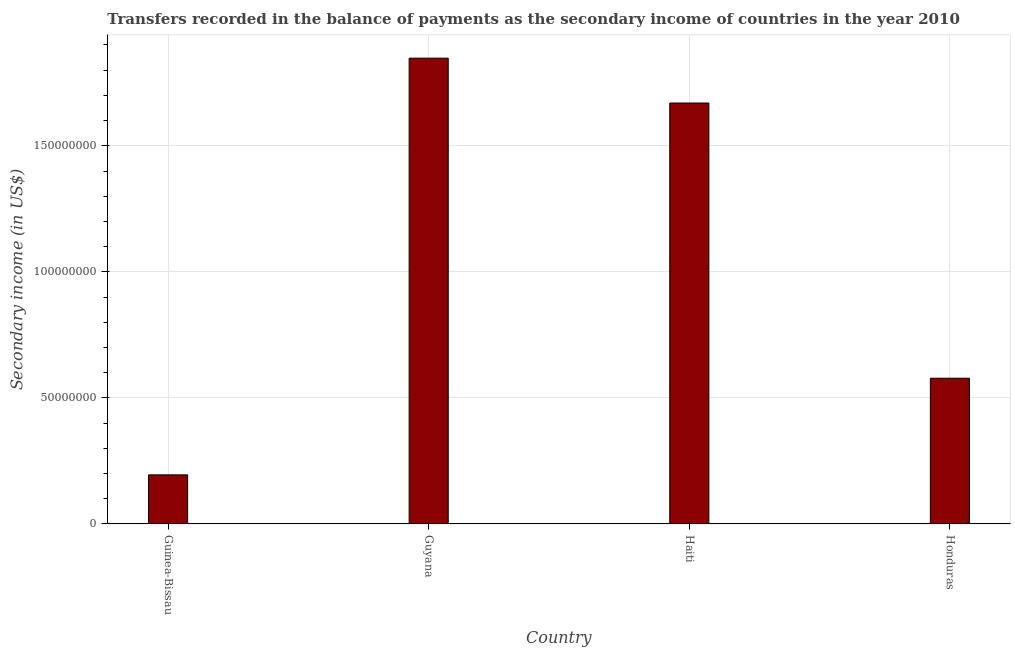Does the graph contain any zero values?
Offer a very short reply. No. What is the title of the graph?
Offer a very short reply. Transfers recorded in the balance of payments as the secondary income of countries in the year 2010. What is the label or title of the Y-axis?
Your answer should be very brief. Secondary income (in US$). What is the amount of secondary income in Haiti?
Offer a terse response. 1.67e+08. Across all countries, what is the maximum amount of secondary income?
Your answer should be compact. 1.85e+08. Across all countries, what is the minimum amount of secondary income?
Give a very brief answer. 1.95e+07. In which country was the amount of secondary income maximum?
Your answer should be compact. Guyana. In which country was the amount of secondary income minimum?
Provide a succinct answer. Guinea-Bissau. What is the sum of the amount of secondary income?
Your answer should be compact. 4.29e+08. What is the difference between the amount of secondary income in Guinea-Bissau and Honduras?
Keep it short and to the point. -3.83e+07. What is the average amount of secondary income per country?
Your answer should be very brief. 1.07e+08. What is the median amount of secondary income?
Give a very brief answer. 1.12e+08. In how many countries, is the amount of secondary income greater than 130000000 US$?
Provide a succinct answer. 2. What is the ratio of the amount of secondary income in Guinea-Bissau to that in Haiti?
Offer a very short reply. 0.12. Is the amount of secondary income in Guinea-Bissau less than that in Guyana?
Provide a succinct answer. Yes. Is the difference between the amount of secondary income in Guyana and Haiti greater than the difference between any two countries?
Your response must be concise. No. What is the difference between the highest and the second highest amount of secondary income?
Provide a short and direct response. 1.78e+07. What is the difference between the highest and the lowest amount of secondary income?
Your answer should be compact. 1.65e+08. How many countries are there in the graph?
Your response must be concise. 4. Are the values on the major ticks of Y-axis written in scientific E-notation?
Your response must be concise. No. What is the Secondary income (in US$) of Guinea-Bissau?
Your answer should be compact. 1.95e+07. What is the Secondary income (in US$) in Guyana?
Your answer should be very brief. 1.85e+08. What is the Secondary income (in US$) in Haiti?
Your answer should be compact. 1.67e+08. What is the Secondary income (in US$) of Honduras?
Offer a very short reply. 5.78e+07. What is the difference between the Secondary income (in US$) in Guinea-Bissau and Guyana?
Provide a short and direct response. -1.65e+08. What is the difference between the Secondary income (in US$) in Guinea-Bissau and Haiti?
Your answer should be compact. -1.47e+08. What is the difference between the Secondary income (in US$) in Guinea-Bissau and Honduras?
Your answer should be compact. -3.83e+07. What is the difference between the Secondary income (in US$) in Guyana and Haiti?
Keep it short and to the point. 1.78e+07. What is the difference between the Secondary income (in US$) in Guyana and Honduras?
Ensure brevity in your answer.  1.27e+08. What is the difference between the Secondary income (in US$) in Haiti and Honduras?
Offer a terse response. 1.09e+08. What is the ratio of the Secondary income (in US$) in Guinea-Bissau to that in Guyana?
Ensure brevity in your answer.  0.1. What is the ratio of the Secondary income (in US$) in Guinea-Bissau to that in Haiti?
Offer a terse response. 0.12. What is the ratio of the Secondary income (in US$) in Guinea-Bissau to that in Honduras?
Keep it short and to the point. 0.34. What is the ratio of the Secondary income (in US$) in Guyana to that in Haiti?
Keep it short and to the point. 1.11. What is the ratio of the Secondary income (in US$) in Guyana to that in Honduras?
Keep it short and to the point. 3.2. What is the ratio of the Secondary income (in US$) in Haiti to that in Honduras?
Offer a very short reply. 2.89. 